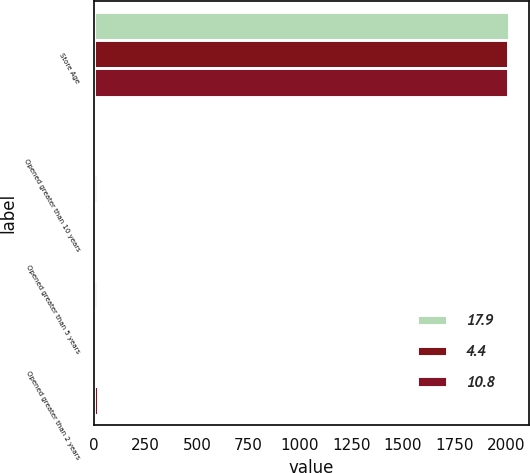Convert chart. <chart><loc_0><loc_0><loc_500><loc_500><stacked_bar_chart><ecel><fcel>Store Age<fcel>Opened greater than 10 years<fcel>Opened greater than 5 years<fcel>Opened greater than 2 years<nl><fcel>17.9<fcel>2013<fcel>2.1<fcel>3.6<fcel>4.4<nl><fcel>4.4<fcel>2012<fcel>8.1<fcel>9.8<fcel>10.8<nl><fcel>10.8<fcel>2011<fcel>15.2<fcel>17.1<fcel>17.9<nl></chart> 